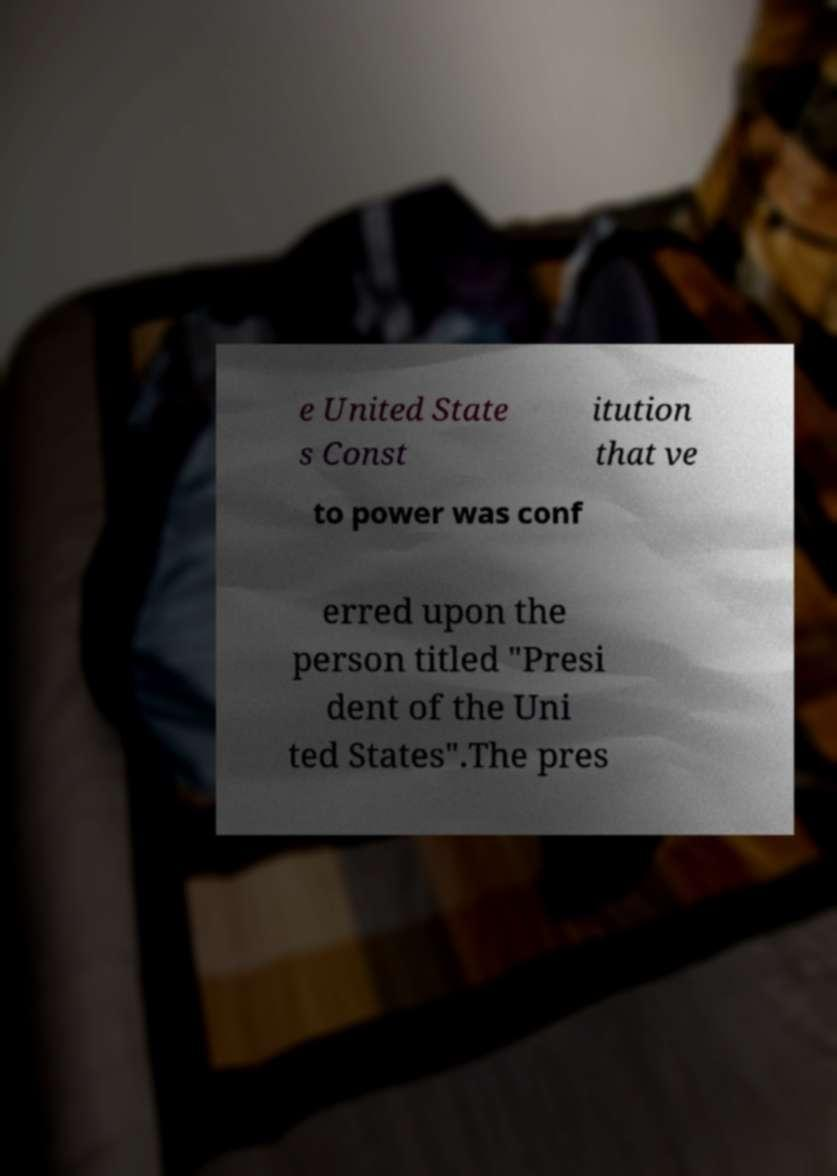What messages or text are displayed in this image? I need them in a readable, typed format. e United State s Const itution that ve to power was conf erred upon the person titled "Presi dent of the Uni ted States".The pres 